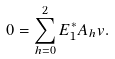Convert formula to latex. <formula><loc_0><loc_0><loc_500><loc_500>0 = \sum _ { h = 0 } ^ { 2 } E ^ { * } _ { 1 } A _ { h } v .</formula> 